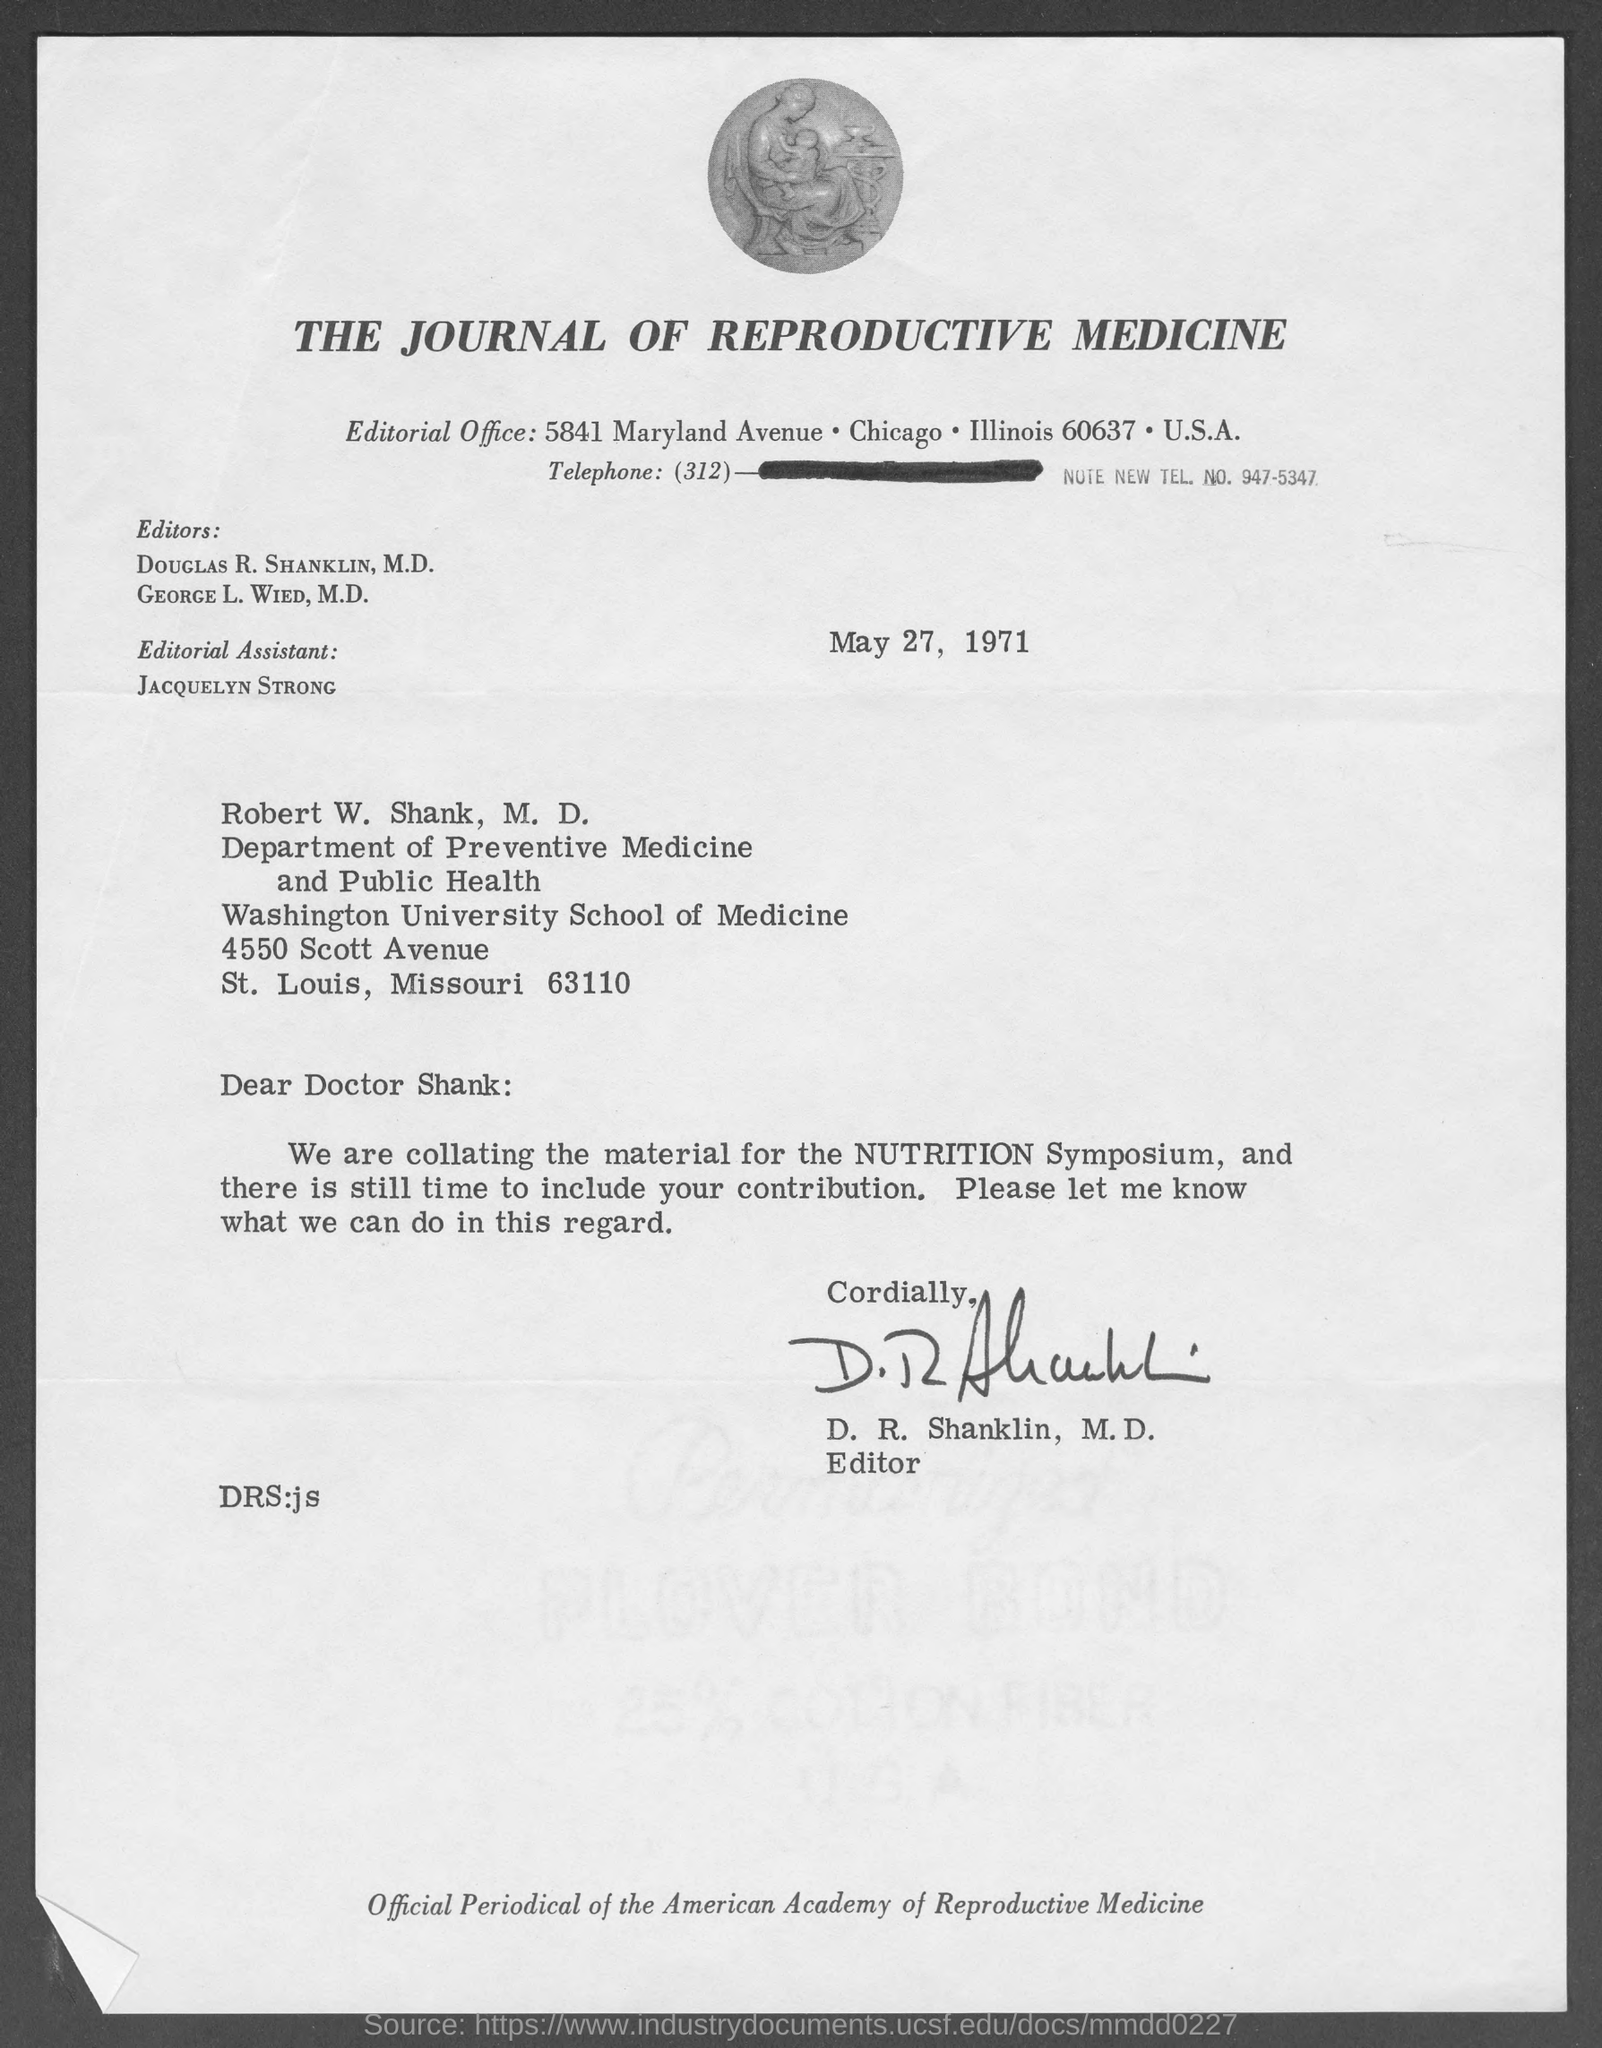What is the Title of the document ?
Offer a very short reply. THE JOURNAL OF REPRODUCTIVE MEDICINE. When is the Memorandum dated on ?
Your answer should be very brief. May 27, 1971. Who is the Memorandum from ?
Ensure brevity in your answer.  D. R. Shanklin, M. D. 